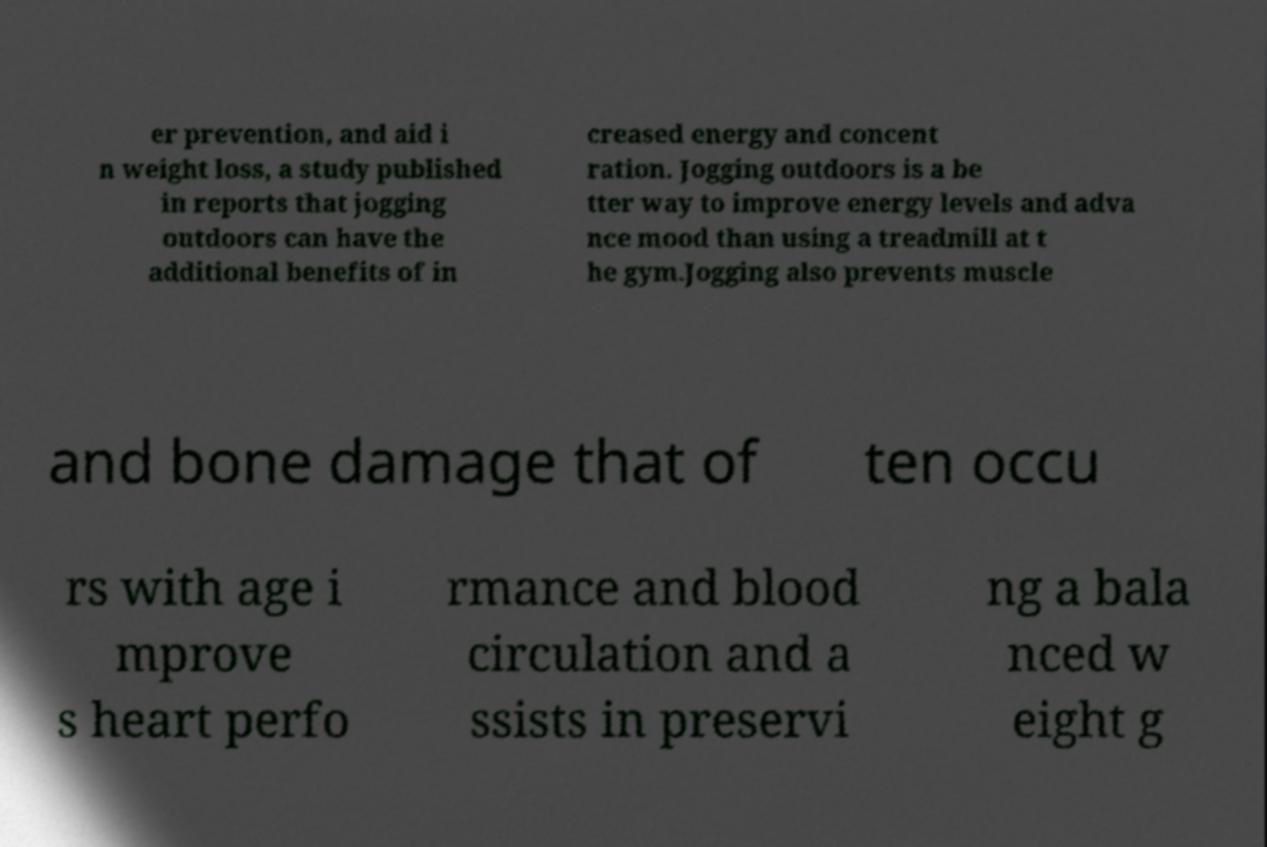Can you accurately transcribe the text from the provided image for me? er prevention, and aid i n weight loss, a study published in reports that jogging outdoors can have the additional benefits of in creased energy and concent ration. Jogging outdoors is a be tter way to improve energy levels and adva nce mood than using a treadmill at t he gym.Jogging also prevents muscle and bone damage that of ten occu rs with age i mprove s heart perfo rmance and blood circulation and a ssists in preservi ng a bala nced w eight g 